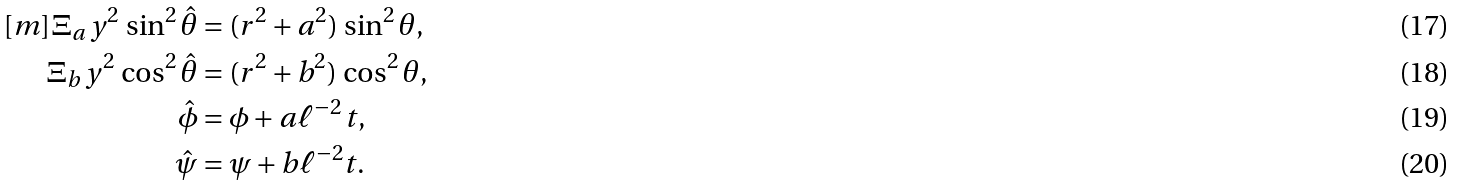<formula> <loc_0><loc_0><loc_500><loc_500>[ m ] \Xi _ { a } \, y ^ { 2 } \, \sin ^ { 2 } \hat { \theta } & = ( r ^ { 2 } + a ^ { 2 } ) \, \sin ^ { 2 } \theta , \\ \Xi _ { b } \, y ^ { 2 } \, \cos ^ { 2 } \hat { \theta } & = ( r ^ { 2 } + b ^ { 2 } ) \, \cos ^ { 2 } \theta , \\ \hat { \phi } & = \phi + a \ell ^ { - 2 } \, t , \\ \hat { \psi } & = \psi + b \ell ^ { - 2 } t .</formula> 